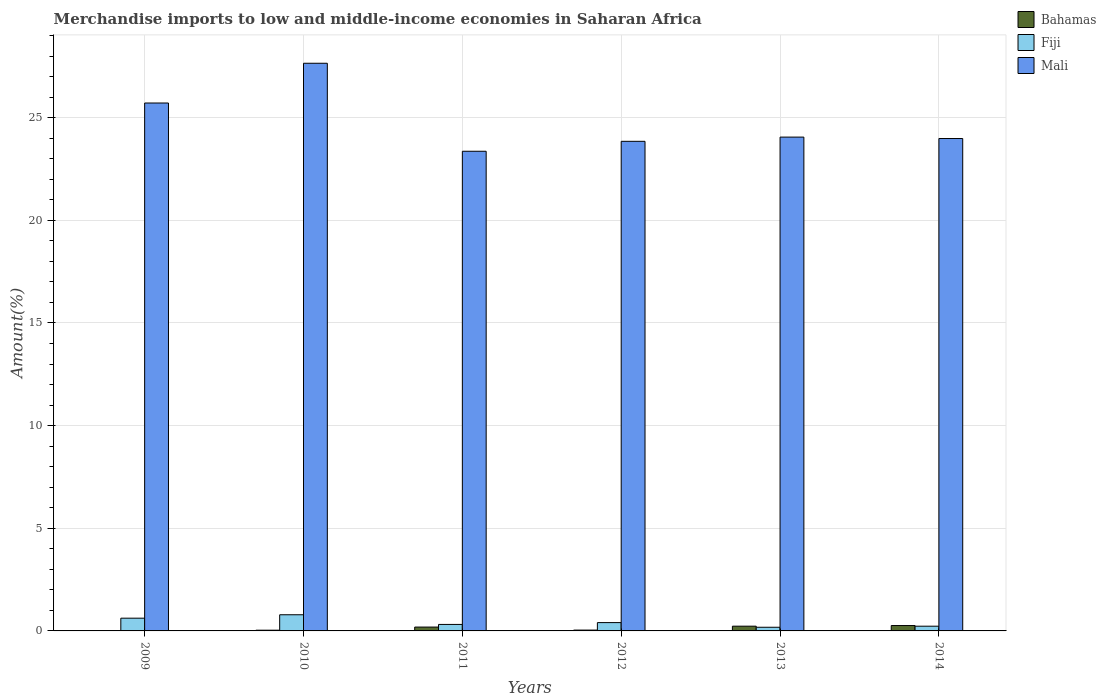How many groups of bars are there?
Offer a very short reply. 6. Are the number of bars on each tick of the X-axis equal?
Your answer should be compact. Yes. What is the percentage of amount earned from merchandise imports in Bahamas in 2013?
Offer a terse response. 0.23. Across all years, what is the maximum percentage of amount earned from merchandise imports in Bahamas?
Provide a short and direct response. 0.26. Across all years, what is the minimum percentage of amount earned from merchandise imports in Fiji?
Offer a very short reply. 0.18. In which year was the percentage of amount earned from merchandise imports in Fiji minimum?
Keep it short and to the point. 2013. What is the total percentage of amount earned from merchandise imports in Fiji in the graph?
Ensure brevity in your answer.  2.54. What is the difference between the percentage of amount earned from merchandise imports in Mali in 2009 and that in 2012?
Ensure brevity in your answer.  1.87. What is the difference between the percentage of amount earned from merchandise imports in Bahamas in 2014 and the percentage of amount earned from merchandise imports in Mali in 2009?
Your answer should be compact. -25.45. What is the average percentage of amount earned from merchandise imports in Fiji per year?
Your answer should be compact. 0.42. In the year 2014, what is the difference between the percentage of amount earned from merchandise imports in Mali and percentage of amount earned from merchandise imports in Bahamas?
Make the answer very short. 23.72. What is the ratio of the percentage of amount earned from merchandise imports in Bahamas in 2009 to that in 2014?
Make the answer very short. 0.06. What is the difference between the highest and the second highest percentage of amount earned from merchandise imports in Fiji?
Provide a short and direct response. 0.17. What is the difference between the highest and the lowest percentage of amount earned from merchandise imports in Mali?
Your answer should be compact. 4.29. Is the sum of the percentage of amount earned from merchandise imports in Fiji in 2011 and 2013 greater than the maximum percentage of amount earned from merchandise imports in Bahamas across all years?
Provide a short and direct response. Yes. What does the 1st bar from the left in 2011 represents?
Your answer should be very brief. Bahamas. What does the 1st bar from the right in 2013 represents?
Make the answer very short. Mali. Is it the case that in every year, the sum of the percentage of amount earned from merchandise imports in Mali and percentage of amount earned from merchandise imports in Bahamas is greater than the percentage of amount earned from merchandise imports in Fiji?
Your response must be concise. Yes. How many bars are there?
Offer a very short reply. 18. Are all the bars in the graph horizontal?
Your answer should be compact. No. How many years are there in the graph?
Offer a terse response. 6. What is the difference between two consecutive major ticks on the Y-axis?
Provide a succinct answer. 5. Are the values on the major ticks of Y-axis written in scientific E-notation?
Your answer should be compact. No. Does the graph contain any zero values?
Provide a short and direct response. No. Does the graph contain grids?
Your response must be concise. Yes. Where does the legend appear in the graph?
Your response must be concise. Top right. How many legend labels are there?
Your response must be concise. 3. What is the title of the graph?
Offer a very short reply. Merchandise imports to low and middle-income economies in Saharan Africa. What is the label or title of the X-axis?
Offer a very short reply. Years. What is the label or title of the Y-axis?
Provide a succinct answer. Amount(%). What is the Amount(%) in Bahamas in 2009?
Ensure brevity in your answer.  0.02. What is the Amount(%) of Fiji in 2009?
Keep it short and to the point. 0.62. What is the Amount(%) of Mali in 2009?
Make the answer very short. 25.72. What is the Amount(%) of Bahamas in 2010?
Your response must be concise. 0.04. What is the Amount(%) in Fiji in 2010?
Keep it short and to the point. 0.79. What is the Amount(%) in Mali in 2010?
Your response must be concise. 27.65. What is the Amount(%) of Bahamas in 2011?
Provide a succinct answer. 0.19. What is the Amount(%) of Fiji in 2011?
Make the answer very short. 0.32. What is the Amount(%) in Mali in 2011?
Offer a very short reply. 23.37. What is the Amount(%) of Bahamas in 2012?
Your response must be concise. 0.04. What is the Amount(%) of Fiji in 2012?
Provide a succinct answer. 0.41. What is the Amount(%) in Mali in 2012?
Keep it short and to the point. 23.85. What is the Amount(%) in Bahamas in 2013?
Your response must be concise. 0.23. What is the Amount(%) in Fiji in 2013?
Give a very brief answer. 0.18. What is the Amount(%) of Mali in 2013?
Offer a very short reply. 24.06. What is the Amount(%) in Bahamas in 2014?
Make the answer very short. 0.26. What is the Amount(%) in Fiji in 2014?
Offer a very short reply. 0.23. What is the Amount(%) in Mali in 2014?
Your answer should be very brief. 23.99. Across all years, what is the maximum Amount(%) in Bahamas?
Provide a short and direct response. 0.26. Across all years, what is the maximum Amount(%) of Fiji?
Offer a very short reply. 0.79. Across all years, what is the maximum Amount(%) in Mali?
Offer a very short reply. 27.65. Across all years, what is the minimum Amount(%) of Bahamas?
Keep it short and to the point. 0.02. Across all years, what is the minimum Amount(%) in Fiji?
Make the answer very short. 0.18. Across all years, what is the minimum Amount(%) in Mali?
Offer a very short reply. 23.37. What is the total Amount(%) of Bahamas in the graph?
Your answer should be compact. 0.77. What is the total Amount(%) of Fiji in the graph?
Your response must be concise. 2.54. What is the total Amount(%) of Mali in the graph?
Your answer should be compact. 148.63. What is the difference between the Amount(%) of Bahamas in 2009 and that in 2010?
Give a very brief answer. -0.02. What is the difference between the Amount(%) in Fiji in 2009 and that in 2010?
Ensure brevity in your answer.  -0.17. What is the difference between the Amount(%) in Mali in 2009 and that in 2010?
Your response must be concise. -1.94. What is the difference between the Amount(%) of Bahamas in 2009 and that in 2011?
Your answer should be compact. -0.17. What is the difference between the Amount(%) in Fiji in 2009 and that in 2011?
Keep it short and to the point. 0.3. What is the difference between the Amount(%) in Mali in 2009 and that in 2011?
Your answer should be compact. 2.35. What is the difference between the Amount(%) in Bahamas in 2009 and that in 2012?
Provide a short and direct response. -0.02. What is the difference between the Amount(%) of Fiji in 2009 and that in 2012?
Keep it short and to the point. 0.22. What is the difference between the Amount(%) of Mali in 2009 and that in 2012?
Make the answer very short. 1.87. What is the difference between the Amount(%) in Bahamas in 2009 and that in 2013?
Your answer should be very brief. -0.21. What is the difference between the Amount(%) in Fiji in 2009 and that in 2013?
Offer a very short reply. 0.44. What is the difference between the Amount(%) of Mali in 2009 and that in 2013?
Make the answer very short. 1.66. What is the difference between the Amount(%) of Bahamas in 2009 and that in 2014?
Your answer should be compact. -0.25. What is the difference between the Amount(%) of Fiji in 2009 and that in 2014?
Offer a very short reply. 0.39. What is the difference between the Amount(%) in Mali in 2009 and that in 2014?
Offer a terse response. 1.73. What is the difference between the Amount(%) in Bahamas in 2010 and that in 2011?
Provide a succinct answer. -0.15. What is the difference between the Amount(%) in Fiji in 2010 and that in 2011?
Your response must be concise. 0.47. What is the difference between the Amount(%) in Mali in 2010 and that in 2011?
Provide a short and direct response. 4.29. What is the difference between the Amount(%) in Bahamas in 2010 and that in 2012?
Give a very brief answer. -0.01. What is the difference between the Amount(%) of Fiji in 2010 and that in 2012?
Make the answer very short. 0.38. What is the difference between the Amount(%) in Mali in 2010 and that in 2012?
Give a very brief answer. 3.8. What is the difference between the Amount(%) in Bahamas in 2010 and that in 2013?
Your answer should be very brief. -0.2. What is the difference between the Amount(%) in Fiji in 2010 and that in 2013?
Offer a terse response. 0.61. What is the difference between the Amount(%) in Mali in 2010 and that in 2013?
Your answer should be compact. 3.6. What is the difference between the Amount(%) in Bahamas in 2010 and that in 2014?
Your answer should be very brief. -0.23. What is the difference between the Amount(%) of Fiji in 2010 and that in 2014?
Offer a terse response. 0.56. What is the difference between the Amount(%) in Mali in 2010 and that in 2014?
Offer a terse response. 3.67. What is the difference between the Amount(%) in Bahamas in 2011 and that in 2012?
Ensure brevity in your answer.  0.15. What is the difference between the Amount(%) of Fiji in 2011 and that in 2012?
Provide a succinct answer. -0.09. What is the difference between the Amount(%) in Mali in 2011 and that in 2012?
Your response must be concise. -0.48. What is the difference between the Amount(%) of Bahamas in 2011 and that in 2013?
Ensure brevity in your answer.  -0.04. What is the difference between the Amount(%) in Fiji in 2011 and that in 2013?
Provide a succinct answer. 0.14. What is the difference between the Amount(%) of Mali in 2011 and that in 2013?
Offer a very short reply. -0.69. What is the difference between the Amount(%) of Bahamas in 2011 and that in 2014?
Offer a very short reply. -0.07. What is the difference between the Amount(%) in Fiji in 2011 and that in 2014?
Give a very brief answer. 0.09. What is the difference between the Amount(%) of Mali in 2011 and that in 2014?
Keep it short and to the point. -0.62. What is the difference between the Amount(%) in Bahamas in 2012 and that in 2013?
Your response must be concise. -0.19. What is the difference between the Amount(%) in Fiji in 2012 and that in 2013?
Provide a short and direct response. 0.23. What is the difference between the Amount(%) in Mali in 2012 and that in 2013?
Provide a short and direct response. -0.21. What is the difference between the Amount(%) in Bahamas in 2012 and that in 2014?
Give a very brief answer. -0.22. What is the difference between the Amount(%) in Fiji in 2012 and that in 2014?
Offer a very short reply. 0.18. What is the difference between the Amount(%) in Mali in 2012 and that in 2014?
Provide a short and direct response. -0.14. What is the difference between the Amount(%) in Bahamas in 2013 and that in 2014?
Your response must be concise. -0.03. What is the difference between the Amount(%) of Fiji in 2013 and that in 2014?
Offer a very short reply. -0.05. What is the difference between the Amount(%) of Mali in 2013 and that in 2014?
Offer a terse response. 0.07. What is the difference between the Amount(%) in Bahamas in 2009 and the Amount(%) in Fiji in 2010?
Your answer should be compact. -0.77. What is the difference between the Amount(%) of Bahamas in 2009 and the Amount(%) of Mali in 2010?
Give a very brief answer. -27.64. What is the difference between the Amount(%) of Fiji in 2009 and the Amount(%) of Mali in 2010?
Make the answer very short. -27.03. What is the difference between the Amount(%) of Bahamas in 2009 and the Amount(%) of Fiji in 2011?
Offer a very short reply. -0.3. What is the difference between the Amount(%) in Bahamas in 2009 and the Amount(%) in Mali in 2011?
Offer a terse response. -23.35. What is the difference between the Amount(%) of Fiji in 2009 and the Amount(%) of Mali in 2011?
Provide a short and direct response. -22.75. What is the difference between the Amount(%) in Bahamas in 2009 and the Amount(%) in Fiji in 2012?
Make the answer very short. -0.39. What is the difference between the Amount(%) in Bahamas in 2009 and the Amount(%) in Mali in 2012?
Provide a succinct answer. -23.83. What is the difference between the Amount(%) in Fiji in 2009 and the Amount(%) in Mali in 2012?
Provide a succinct answer. -23.23. What is the difference between the Amount(%) in Bahamas in 2009 and the Amount(%) in Fiji in 2013?
Keep it short and to the point. -0.16. What is the difference between the Amount(%) of Bahamas in 2009 and the Amount(%) of Mali in 2013?
Give a very brief answer. -24.04. What is the difference between the Amount(%) in Fiji in 2009 and the Amount(%) in Mali in 2013?
Ensure brevity in your answer.  -23.43. What is the difference between the Amount(%) of Bahamas in 2009 and the Amount(%) of Fiji in 2014?
Provide a short and direct response. -0.21. What is the difference between the Amount(%) of Bahamas in 2009 and the Amount(%) of Mali in 2014?
Offer a terse response. -23.97. What is the difference between the Amount(%) of Fiji in 2009 and the Amount(%) of Mali in 2014?
Make the answer very short. -23.37. What is the difference between the Amount(%) of Bahamas in 2010 and the Amount(%) of Fiji in 2011?
Give a very brief answer. -0.28. What is the difference between the Amount(%) of Bahamas in 2010 and the Amount(%) of Mali in 2011?
Give a very brief answer. -23.33. What is the difference between the Amount(%) of Fiji in 2010 and the Amount(%) of Mali in 2011?
Provide a succinct answer. -22.58. What is the difference between the Amount(%) of Bahamas in 2010 and the Amount(%) of Fiji in 2012?
Your answer should be compact. -0.37. What is the difference between the Amount(%) in Bahamas in 2010 and the Amount(%) in Mali in 2012?
Make the answer very short. -23.81. What is the difference between the Amount(%) of Fiji in 2010 and the Amount(%) of Mali in 2012?
Provide a succinct answer. -23.06. What is the difference between the Amount(%) of Bahamas in 2010 and the Amount(%) of Fiji in 2013?
Make the answer very short. -0.14. What is the difference between the Amount(%) in Bahamas in 2010 and the Amount(%) in Mali in 2013?
Provide a succinct answer. -24.02. What is the difference between the Amount(%) in Fiji in 2010 and the Amount(%) in Mali in 2013?
Keep it short and to the point. -23.27. What is the difference between the Amount(%) in Bahamas in 2010 and the Amount(%) in Fiji in 2014?
Offer a very short reply. -0.19. What is the difference between the Amount(%) in Bahamas in 2010 and the Amount(%) in Mali in 2014?
Make the answer very short. -23.95. What is the difference between the Amount(%) of Fiji in 2010 and the Amount(%) of Mali in 2014?
Ensure brevity in your answer.  -23.2. What is the difference between the Amount(%) in Bahamas in 2011 and the Amount(%) in Fiji in 2012?
Provide a short and direct response. -0.22. What is the difference between the Amount(%) in Bahamas in 2011 and the Amount(%) in Mali in 2012?
Provide a succinct answer. -23.66. What is the difference between the Amount(%) of Fiji in 2011 and the Amount(%) of Mali in 2012?
Provide a short and direct response. -23.53. What is the difference between the Amount(%) of Bahamas in 2011 and the Amount(%) of Fiji in 2013?
Offer a very short reply. 0.01. What is the difference between the Amount(%) of Bahamas in 2011 and the Amount(%) of Mali in 2013?
Offer a very short reply. -23.87. What is the difference between the Amount(%) of Fiji in 2011 and the Amount(%) of Mali in 2013?
Provide a short and direct response. -23.74. What is the difference between the Amount(%) of Bahamas in 2011 and the Amount(%) of Fiji in 2014?
Your answer should be very brief. -0.04. What is the difference between the Amount(%) of Bahamas in 2011 and the Amount(%) of Mali in 2014?
Provide a short and direct response. -23.8. What is the difference between the Amount(%) in Fiji in 2011 and the Amount(%) in Mali in 2014?
Your answer should be compact. -23.67. What is the difference between the Amount(%) in Bahamas in 2012 and the Amount(%) in Fiji in 2013?
Your response must be concise. -0.14. What is the difference between the Amount(%) in Bahamas in 2012 and the Amount(%) in Mali in 2013?
Your answer should be very brief. -24.01. What is the difference between the Amount(%) in Fiji in 2012 and the Amount(%) in Mali in 2013?
Give a very brief answer. -23.65. What is the difference between the Amount(%) of Bahamas in 2012 and the Amount(%) of Fiji in 2014?
Offer a terse response. -0.19. What is the difference between the Amount(%) of Bahamas in 2012 and the Amount(%) of Mali in 2014?
Your answer should be compact. -23.95. What is the difference between the Amount(%) in Fiji in 2012 and the Amount(%) in Mali in 2014?
Your answer should be compact. -23.58. What is the difference between the Amount(%) of Bahamas in 2013 and the Amount(%) of Mali in 2014?
Your response must be concise. -23.76. What is the difference between the Amount(%) in Fiji in 2013 and the Amount(%) in Mali in 2014?
Provide a short and direct response. -23.81. What is the average Amount(%) in Bahamas per year?
Offer a very short reply. 0.13. What is the average Amount(%) in Fiji per year?
Provide a short and direct response. 0.42. What is the average Amount(%) in Mali per year?
Provide a succinct answer. 24.77. In the year 2009, what is the difference between the Amount(%) in Bahamas and Amount(%) in Fiji?
Your answer should be compact. -0.6. In the year 2009, what is the difference between the Amount(%) in Bahamas and Amount(%) in Mali?
Your response must be concise. -25.7. In the year 2009, what is the difference between the Amount(%) in Fiji and Amount(%) in Mali?
Provide a succinct answer. -25.1. In the year 2010, what is the difference between the Amount(%) of Bahamas and Amount(%) of Fiji?
Make the answer very short. -0.75. In the year 2010, what is the difference between the Amount(%) of Bahamas and Amount(%) of Mali?
Your response must be concise. -27.62. In the year 2010, what is the difference between the Amount(%) of Fiji and Amount(%) of Mali?
Your answer should be very brief. -26.87. In the year 2011, what is the difference between the Amount(%) of Bahamas and Amount(%) of Fiji?
Give a very brief answer. -0.13. In the year 2011, what is the difference between the Amount(%) in Bahamas and Amount(%) in Mali?
Offer a very short reply. -23.18. In the year 2011, what is the difference between the Amount(%) in Fiji and Amount(%) in Mali?
Offer a very short reply. -23.05. In the year 2012, what is the difference between the Amount(%) of Bahamas and Amount(%) of Fiji?
Offer a terse response. -0.36. In the year 2012, what is the difference between the Amount(%) in Bahamas and Amount(%) in Mali?
Provide a short and direct response. -23.81. In the year 2012, what is the difference between the Amount(%) in Fiji and Amount(%) in Mali?
Provide a short and direct response. -23.44. In the year 2013, what is the difference between the Amount(%) in Bahamas and Amount(%) in Fiji?
Make the answer very short. 0.05. In the year 2013, what is the difference between the Amount(%) of Bahamas and Amount(%) of Mali?
Make the answer very short. -23.82. In the year 2013, what is the difference between the Amount(%) in Fiji and Amount(%) in Mali?
Provide a short and direct response. -23.88. In the year 2014, what is the difference between the Amount(%) of Bahamas and Amount(%) of Fiji?
Ensure brevity in your answer.  0.03. In the year 2014, what is the difference between the Amount(%) in Bahamas and Amount(%) in Mali?
Provide a succinct answer. -23.72. In the year 2014, what is the difference between the Amount(%) in Fiji and Amount(%) in Mali?
Ensure brevity in your answer.  -23.76. What is the ratio of the Amount(%) of Bahamas in 2009 to that in 2010?
Provide a short and direct response. 0.47. What is the ratio of the Amount(%) of Fiji in 2009 to that in 2010?
Offer a very short reply. 0.79. What is the ratio of the Amount(%) of Mali in 2009 to that in 2010?
Offer a terse response. 0.93. What is the ratio of the Amount(%) in Bahamas in 2009 to that in 2011?
Your answer should be very brief. 0.09. What is the ratio of the Amount(%) in Fiji in 2009 to that in 2011?
Give a very brief answer. 1.96. What is the ratio of the Amount(%) in Mali in 2009 to that in 2011?
Offer a very short reply. 1.1. What is the ratio of the Amount(%) of Bahamas in 2009 to that in 2012?
Your answer should be very brief. 0.41. What is the ratio of the Amount(%) of Fiji in 2009 to that in 2012?
Offer a terse response. 1.53. What is the ratio of the Amount(%) of Mali in 2009 to that in 2012?
Make the answer very short. 1.08. What is the ratio of the Amount(%) of Bahamas in 2009 to that in 2013?
Ensure brevity in your answer.  0.07. What is the ratio of the Amount(%) in Fiji in 2009 to that in 2013?
Offer a very short reply. 3.47. What is the ratio of the Amount(%) of Mali in 2009 to that in 2013?
Provide a short and direct response. 1.07. What is the ratio of the Amount(%) in Bahamas in 2009 to that in 2014?
Offer a terse response. 0.06. What is the ratio of the Amount(%) of Fiji in 2009 to that in 2014?
Keep it short and to the point. 2.7. What is the ratio of the Amount(%) in Mali in 2009 to that in 2014?
Provide a short and direct response. 1.07. What is the ratio of the Amount(%) in Bahamas in 2010 to that in 2011?
Make the answer very short. 0.19. What is the ratio of the Amount(%) of Fiji in 2010 to that in 2011?
Your response must be concise. 2.49. What is the ratio of the Amount(%) in Mali in 2010 to that in 2011?
Your response must be concise. 1.18. What is the ratio of the Amount(%) in Bahamas in 2010 to that in 2012?
Provide a succinct answer. 0.87. What is the ratio of the Amount(%) of Fiji in 2010 to that in 2012?
Provide a short and direct response. 1.94. What is the ratio of the Amount(%) of Mali in 2010 to that in 2012?
Offer a terse response. 1.16. What is the ratio of the Amount(%) of Bahamas in 2010 to that in 2013?
Make the answer very short. 0.15. What is the ratio of the Amount(%) of Fiji in 2010 to that in 2013?
Your answer should be compact. 4.4. What is the ratio of the Amount(%) in Mali in 2010 to that in 2013?
Provide a short and direct response. 1.15. What is the ratio of the Amount(%) of Bahamas in 2010 to that in 2014?
Keep it short and to the point. 0.14. What is the ratio of the Amount(%) of Fiji in 2010 to that in 2014?
Your answer should be compact. 3.42. What is the ratio of the Amount(%) in Mali in 2010 to that in 2014?
Your answer should be compact. 1.15. What is the ratio of the Amount(%) in Bahamas in 2011 to that in 2012?
Make the answer very short. 4.61. What is the ratio of the Amount(%) in Fiji in 2011 to that in 2012?
Your answer should be very brief. 0.78. What is the ratio of the Amount(%) in Mali in 2011 to that in 2012?
Your response must be concise. 0.98. What is the ratio of the Amount(%) in Bahamas in 2011 to that in 2013?
Your answer should be very brief. 0.81. What is the ratio of the Amount(%) in Fiji in 2011 to that in 2013?
Your answer should be compact. 1.77. What is the ratio of the Amount(%) of Mali in 2011 to that in 2013?
Your answer should be very brief. 0.97. What is the ratio of the Amount(%) of Bahamas in 2011 to that in 2014?
Make the answer very short. 0.71. What is the ratio of the Amount(%) in Fiji in 2011 to that in 2014?
Provide a short and direct response. 1.37. What is the ratio of the Amount(%) in Mali in 2011 to that in 2014?
Give a very brief answer. 0.97. What is the ratio of the Amount(%) in Bahamas in 2012 to that in 2013?
Ensure brevity in your answer.  0.18. What is the ratio of the Amount(%) of Fiji in 2012 to that in 2013?
Make the answer very short. 2.27. What is the ratio of the Amount(%) in Bahamas in 2012 to that in 2014?
Offer a terse response. 0.16. What is the ratio of the Amount(%) of Fiji in 2012 to that in 2014?
Offer a very short reply. 1.76. What is the ratio of the Amount(%) in Mali in 2012 to that in 2014?
Offer a terse response. 0.99. What is the ratio of the Amount(%) in Bahamas in 2013 to that in 2014?
Provide a succinct answer. 0.88. What is the ratio of the Amount(%) of Fiji in 2013 to that in 2014?
Keep it short and to the point. 0.78. What is the difference between the highest and the second highest Amount(%) in Bahamas?
Provide a succinct answer. 0.03. What is the difference between the highest and the second highest Amount(%) in Mali?
Provide a short and direct response. 1.94. What is the difference between the highest and the lowest Amount(%) of Bahamas?
Give a very brief answer. 0.25. What is the difference between the highest and the lowest Amount(%) in Fiji?
Offer a very short reply. 0.61. What is the difference between the highest and the lowest Amount(%) of Mali?
Provide a short and direct response. 4.29. 